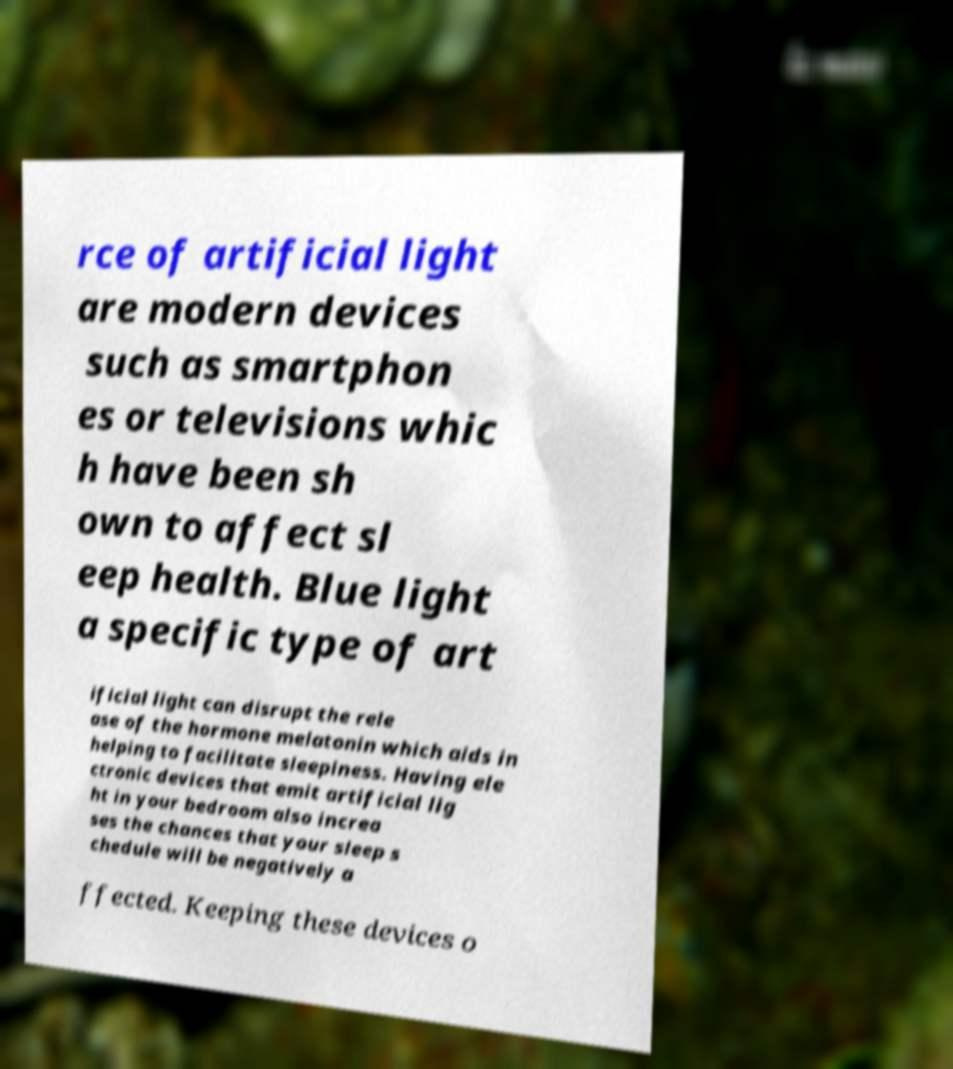What messages or text are displayed in this image? I need them in a readable, typed format. rce of artificial light are modern devices such as smartphon es or televisions whic h have been sh own to affect sl eep health. Blue light a specific type of art ificial light can disrupt the rele ase of the hormone melatonin which aids in helping to facilitate sleepiness. Having ele ctronic devices that emit artificial lig ht in your bedroom also increa ses the chances that your sleep s chedule will be negatively a ffected. Keeping these devices o 